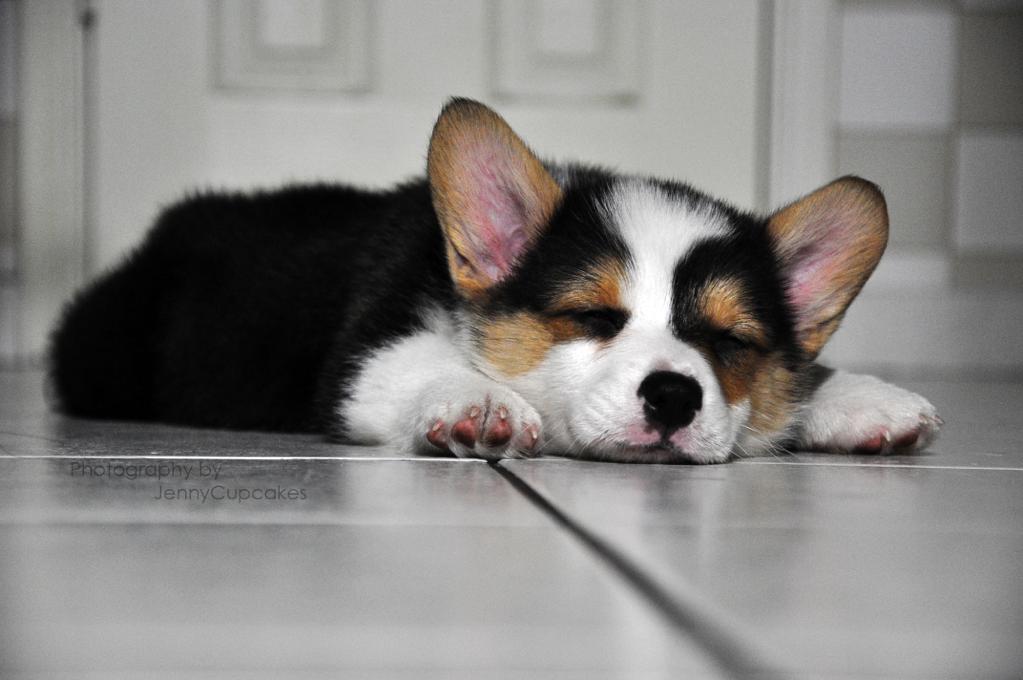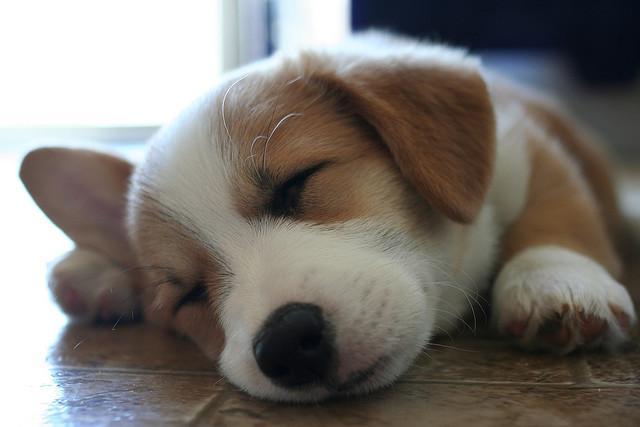The first image is the image on the left, the second image is the image on the right. Analyze the images presented: Is the assertion "There are exactly two dogs." valid? Answer yes or no. Yes. The first image is the image on the left, the second image is the image on the right. Considering the images on both sides, is "One image shows dogs asleep and the other image shows dogs awake." valid? Answer yes or no. No. 